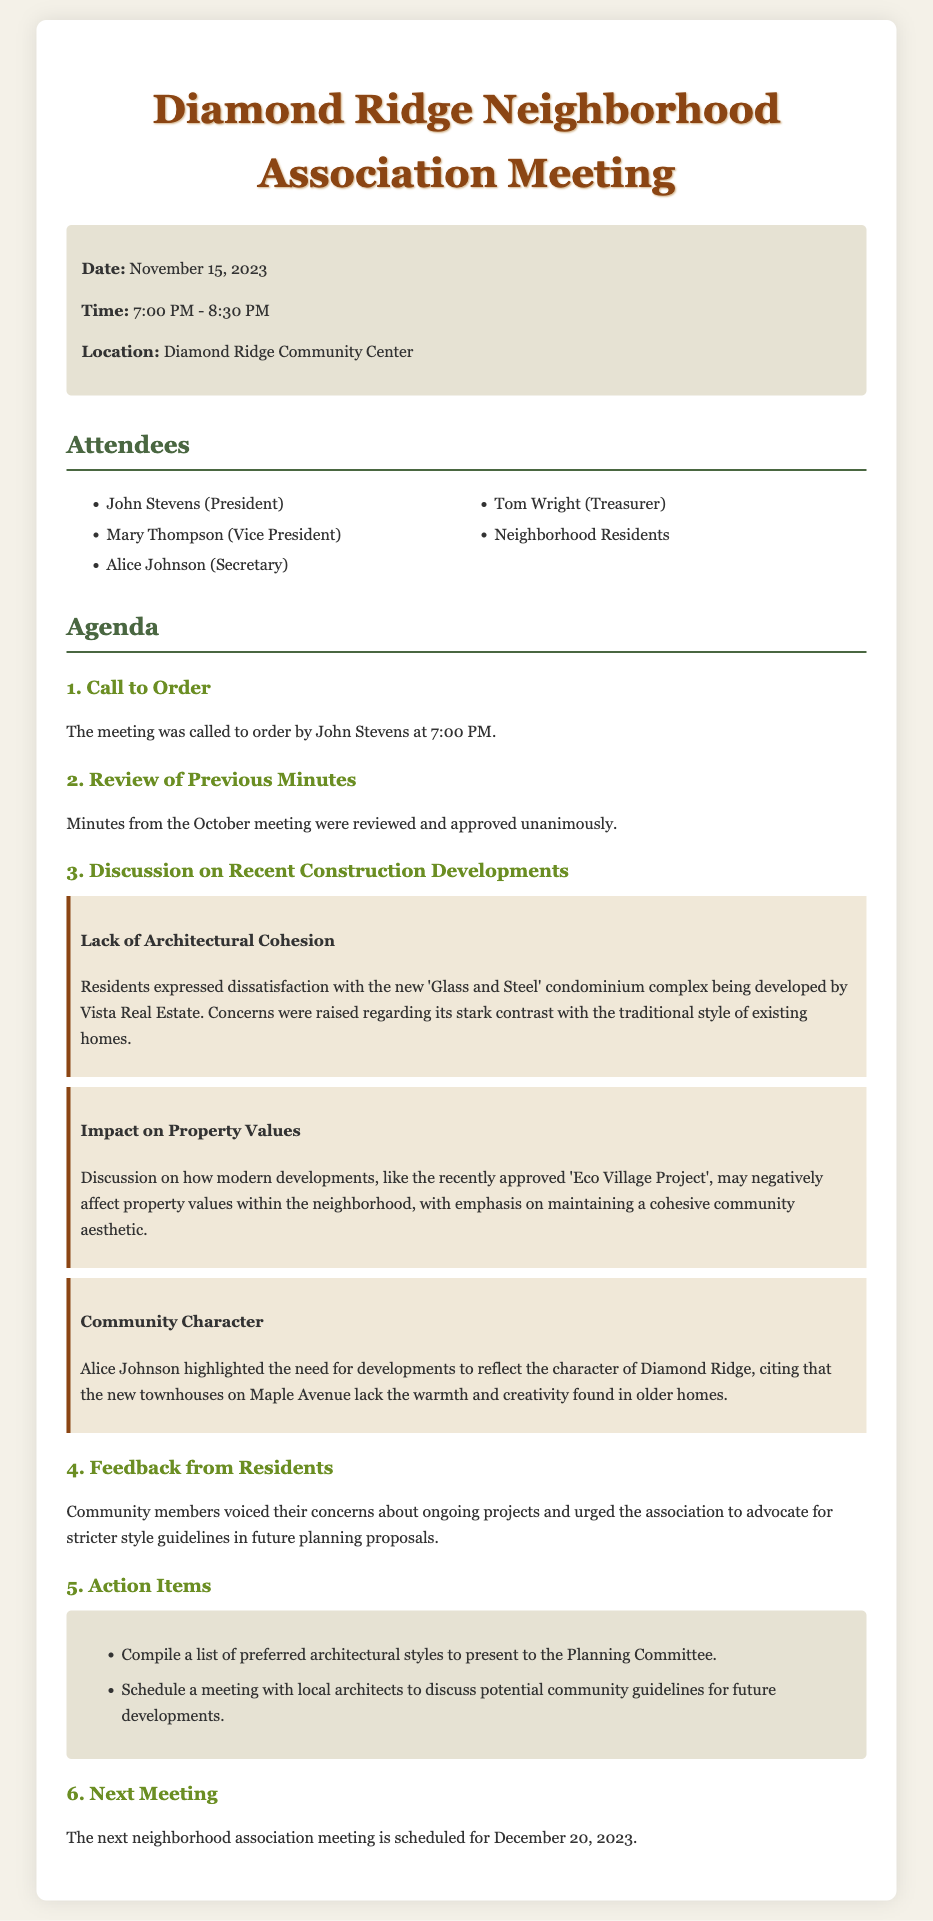What is the date of the meeting? The date of the meeting is explicitly mentioned in the meeting info section.
Answer: November 15, 2023 Who expressed dissatisfaction with the new condominium complex? The document identifies a specific resident who raised concerns about the construction developments.
Answer: Residents What is the name of the 'Eco Village Project'? The name refers to a specific project that is discussed in the meeting in relation to property values.
Answer: Eco Village Project What architectural style did residents prefer? The action items indicate that residents want to compile a list of preferred styles to present to the Planning Committee.
Answer: Preferred architectural styles What was the main concern highlighted by Alice Johnson? Alice's concern pertains to the character of the neighborhood and the aesthetics of new developments.
Answer: Community character Which month will the next neighborhood association meeting be held? The information in the agenda specifies the timing of the next meeting scheduled after this one.
Answer: December How many action items were listed in the document? The action items section outlines specific tasks and includes a list format indicating the number of items.
Answer: Two What does the association advocate for in future planning proposals? The feedback section from residents emphasizes a specific need related to future projects.
Answer: Stricter style guidelines 